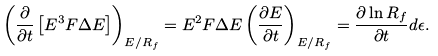<formula> <loc_0><loc_0><loc_500><loc_500>\left ( \frac { \partial } { \partial t } \left [ E ^ { 3 } F \Delta E \right ] \right ) _ { E / R _ { f } } = E ^ { 2 } F \Delta E \left ( \frac { \partial E } { \partial t } \right ) _ { E / R _ { f } } = \frac { \partial \ln R _ { f } } { \partial t } d \epsilon .</formula> 